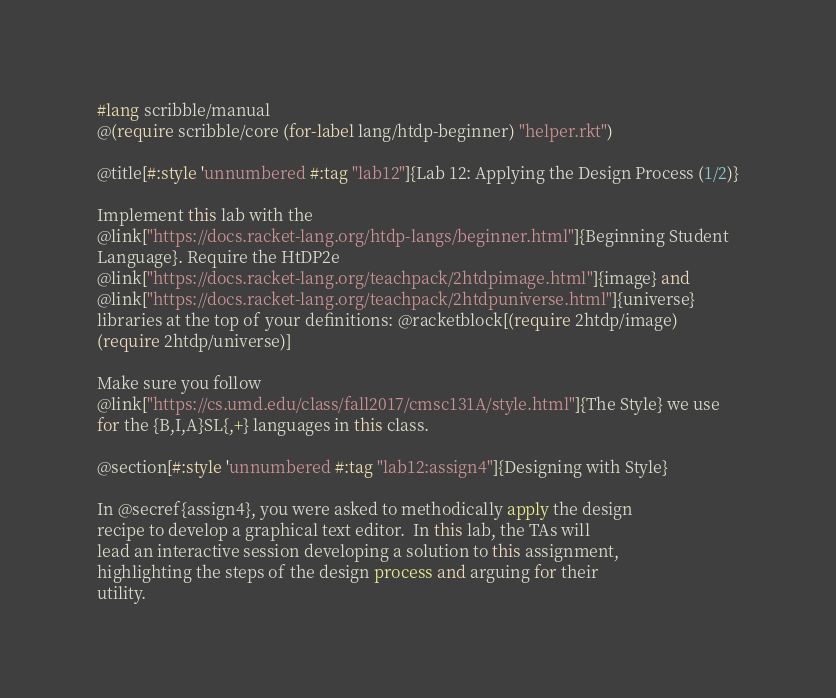<code> <loc_0><loc_0><loc_500><loc_500><_Racket_>#lang scribble/manual
@(require scribble/core (for-label lang/htdp-beginner) "helper.rkt")

@title[#:style 'unnumbered #:tag "lab12"]{Lab 12: Applying the Design Process (1/2)}

Implement this lab with the
@link["https://docs.racket-lang.org/htdp-langs/beginner.html"]{Beginning Student
Language}. Require the HtDP2e
@link["https://docs.racket-lang.org/teachpack/2htdpimage.html"]{image} and
@link["https://docs.racket-lang.org/teachpack/2htdpuniverse.html"]{universe}
libraries at the top of your definitions: @racketblock[(require 2htdp/image)
(require 2htdp/universe)]

Make sure you follow
@link["https://cs.umd.edu/class/fall2017/cmsc131A/style.html"]{The Style} we use
for the {B,I,A}SL{,+} languages in this class.

@section[#:style 'unnumbered #:tag "lab12:assign4"]{Designing with Style}

In @secref{assign4}, you were asked to methodically apply the design
recipe to develop a graphical text editor.  In this lab, the TAs will
lead an interactive session developing a solution to this assignment,
highlighting the steps of the design process and arguing for their
utility.
</code> 